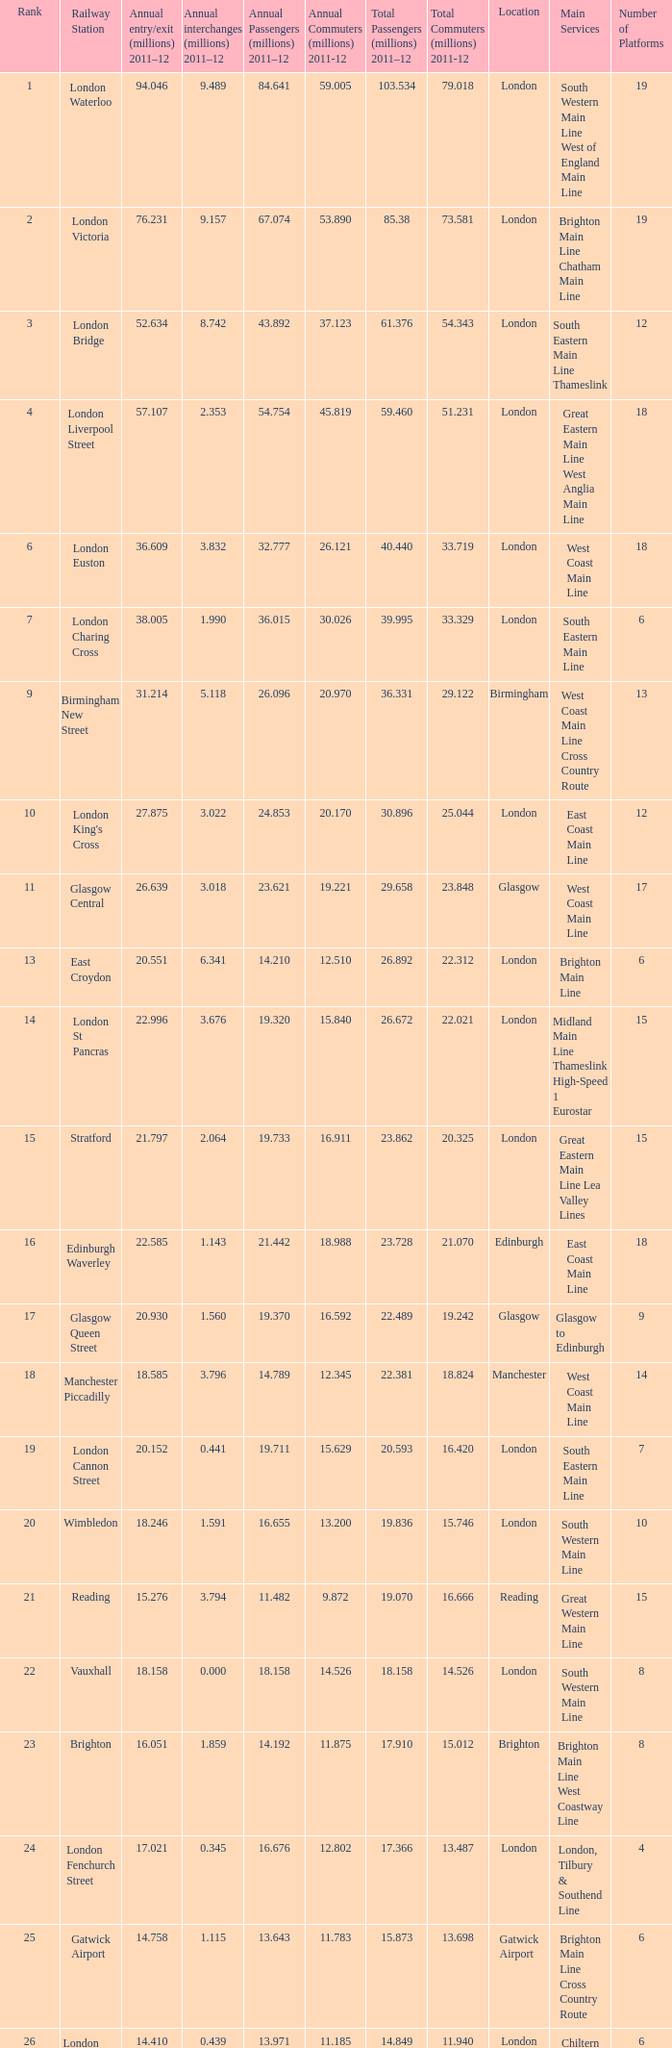How many annual interchanges in the millions occurred in 2011-12 when the number of annual entry/exits was 36.609 million?  3.832. 